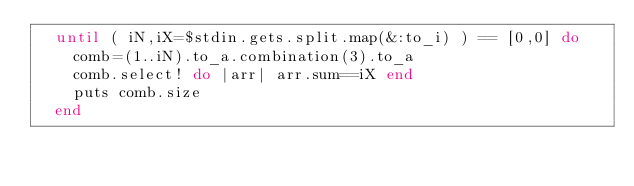Convert code to text. <code><loc_0><loc_0><loc_500><loc_500><_Ruby_>  until ( iN,iX=$stdin.gets.split.map(&:to_i) ) == [0,0] do
    comb=(1..iN).to_a.combination(3).to_a
    comb.select! do |arr| arr.sum==iX end
    puts comb.size
  end
</code> 